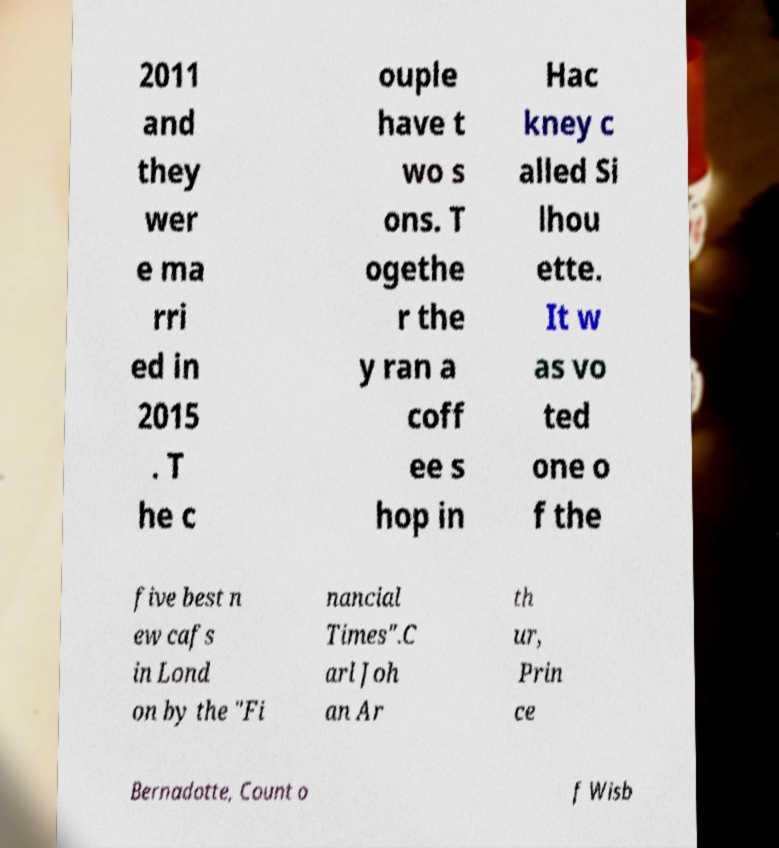Could you extract and type out the text from this image? 2011 and they wer e ma rri ed in 2015 . T he c ouple have t wo s ons. T ogethe r the y ran a coff ee s hop in Hac kney c alled Si lhou ette. It w as vo ted one o f the five best n ew cafs in Lond on by the "Fi nancial Times".C arl Joh an Ar th ur, Prin ce Bernadotte, Count o f Wisb 